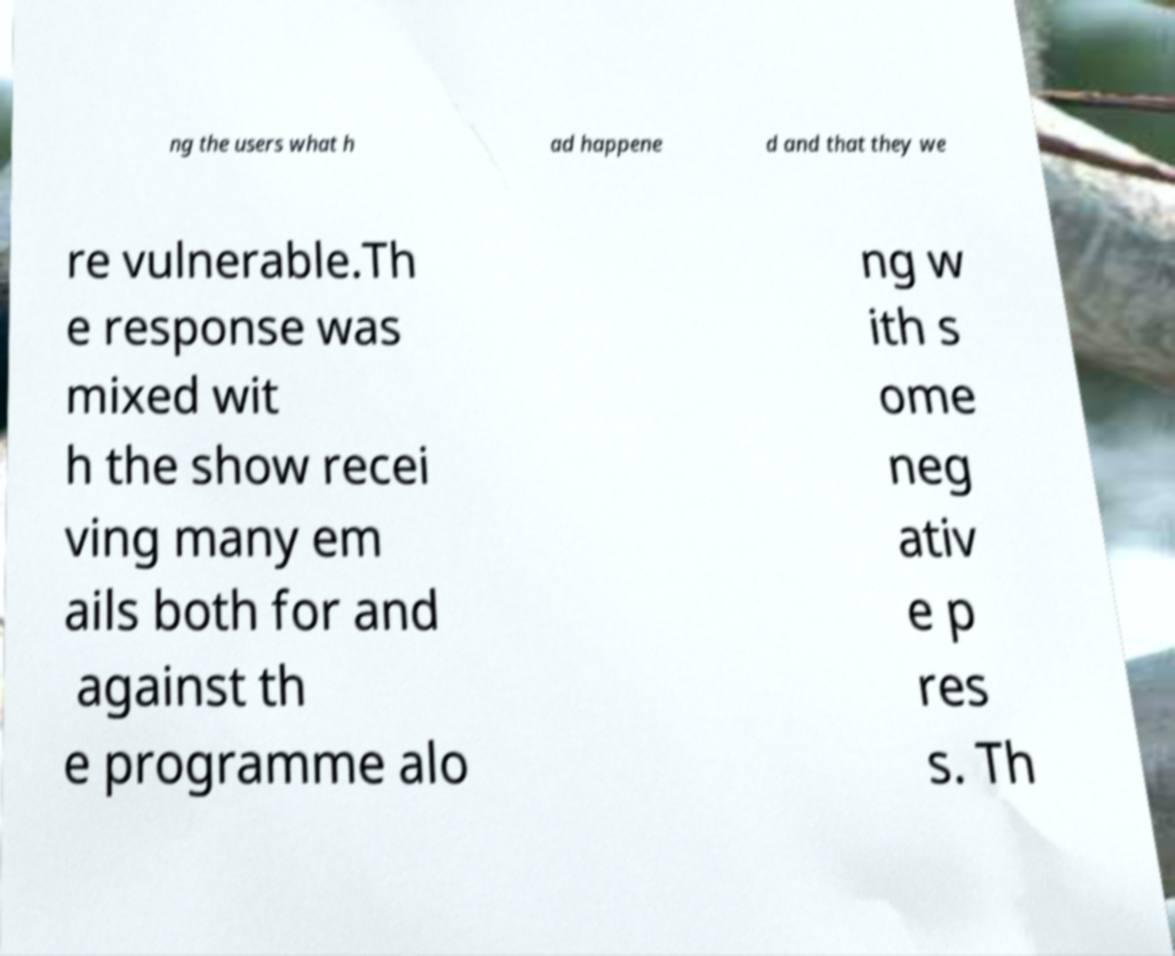Can you accurately transcribe the text from the provided image for me? ng the users what h ad happene d and that they we re vulnerable.Th e response was mixed wit h the show recei ving many em ails both for and against th e programme alo ng w ith s ome neg ativ e p res s. Th 